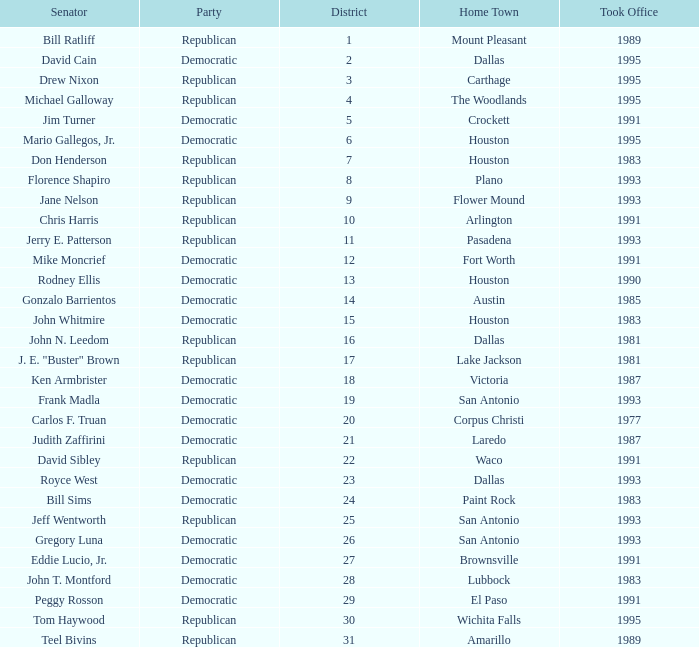Can you parse all the data within this table? {'header': ['Senator', 'Party', 'District', 'Home Town', 'Took Office'], 'rows': [['Bill Ratliff', 'Republican', '1', 'Mount Pleasant', '1989'], ['David Cain', 'Democratic', '2', 'Dallas', '1995'], ['Drew Nixon', 'Republican', '3', 'Carthage', '1995'], ['Michael Galloway', 'Republican', '4', 'The Woodlands', '1995'], ['Jim Turner', 'Democratic', '5', 'Crockett', '1991'], ['Mario Gallegos, Jr.', 'Democratic', '6', 'Houston', '1995'], ['Don Henderson', 'Republican', '7', 'Houston', '1983'], ['Florence Shapiro', 'Republican', '8', 'Plano', '1993'], ['Jane Nelson', 'Republican', '9', 'Flower Mound', '1993'], ['Chris Harris', 'Republican', '10', 'Arlington', '1991'], ['Jerry E. Patterson', 'Republican', '11', 'Pasadena', '1993'], ['Mike Moncrief', 'Democratic', '12', 'Fort Worth', '1991'], ['Rodney Ellis', 'Democratic', '13', 'Houston', '1990'], ['Gonzalo Barrientos', 'Democratic', '14', 'Austin', '1985'], ['John Whitmire', 'Democratic', '15', 'Houston', '1983'], ['John N. Leedom', 'Republican', '16', 'Dallas', '1981'], ['J. E. "Buster" Brown', 'Republican', '17', 'Lake Jackson', '1981'], ['Ken Armbrister', 'Democratic', '18', 'Victoria', '1987'], ['Frank Madla', 'Democratic', '19', 'San Antonio', '1993'], ['Carlos F. Truan', 'Democratic', '20', 'Corpus Christi', '1977'], ['Judith Zaffirini', 'Democratic', '21', 'Laredo', '1987'], ['David Sibley', 'Republican', '22', 'Waco', '1991'], ['Royce West', 'Democratic', '23', 'Dallas', '1993'], ['Bill Sims', 'Democratic', '24', 'Paint Rock', '1983'], ['Jeff Wentworth', 'Republican', '25', 'San Antonio', '1993'], ['Gregory Luna', 'Democratic', '26', 'San Antonio', '1993'], ['Eddie Lucio, Jr.', 'Democratic', '27', 'Brownsville', '1991'], ['John T. Montford', 'Democratic', '28', 'Lubbock', '1983'], ['Peggy Rosson', 'Democratic', '29', 'El Paso', '1991'], ['Tom Haywood', 'Republican', '30', 'Wichita Falls', '1995'], ['Teel Bivins', 'Republican', '31', 'Amarillo', '1989']]} Which party came into power after 1993 alongside senator michael galloway? Republican. 